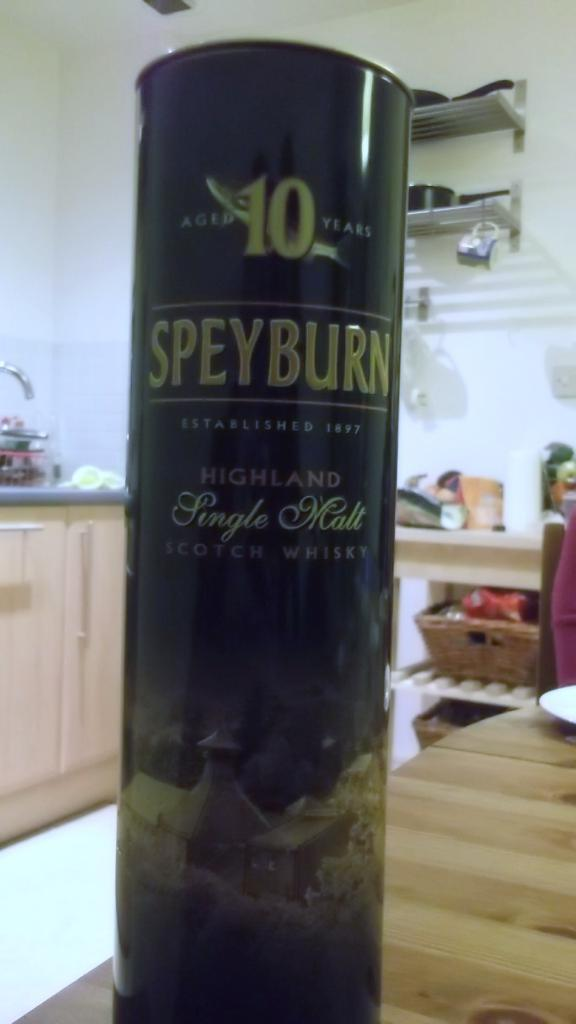<image>
Render a clear and concise summary of the photo. A black container that says Speyburn on it. 